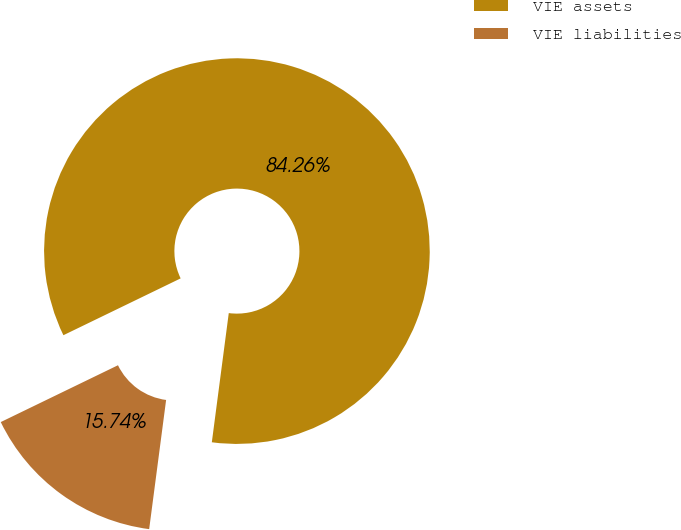Convert chart. <chart><loc_0><loc_0><loc_500><loc_500><pie_chart><fcel>VIE assets<fcel>VIE liabilities<nl><fcel>84.26%<fcel>15.74%<nl></chart> 